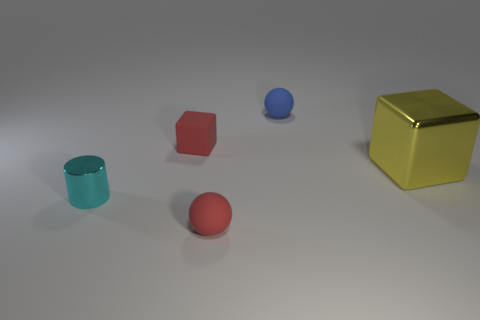What is the material of the tiny ball that is the same color as the tiny rubber cube?
Keep it short and to the point. Rubber. There is a metallic thing that is to the right of the metal cylinder; is there a small cyan cylinder that is left of it?
Your response must be concise. Yes. What is the material of the blue ball?
Provide a succinct answer. Rubber. Are there any objects in front of the shiny cylinder?
Make the answer very short. Yes. What is the size of the red rubber thing that is the same shape as the big metallic object?
Offer a terse response. Small. Are there an equal number of metal blocks that are left of the red ball and red rubber things behind the small shiny cylinder?
Offer a terse response. No. What number of tiny red balls are there?
Offer a very short reply. 1. Are there more red blocks behind the cyan thing than purple metal spheres?
Offer a very short reply. Yes. There is a cyan cylinder that is in front of the small blue rubber thing; what is its material?
Give a very brief answer. Metal. What number of matte things are the same color as the matte cube?
Provide a short and direct response. 1. 